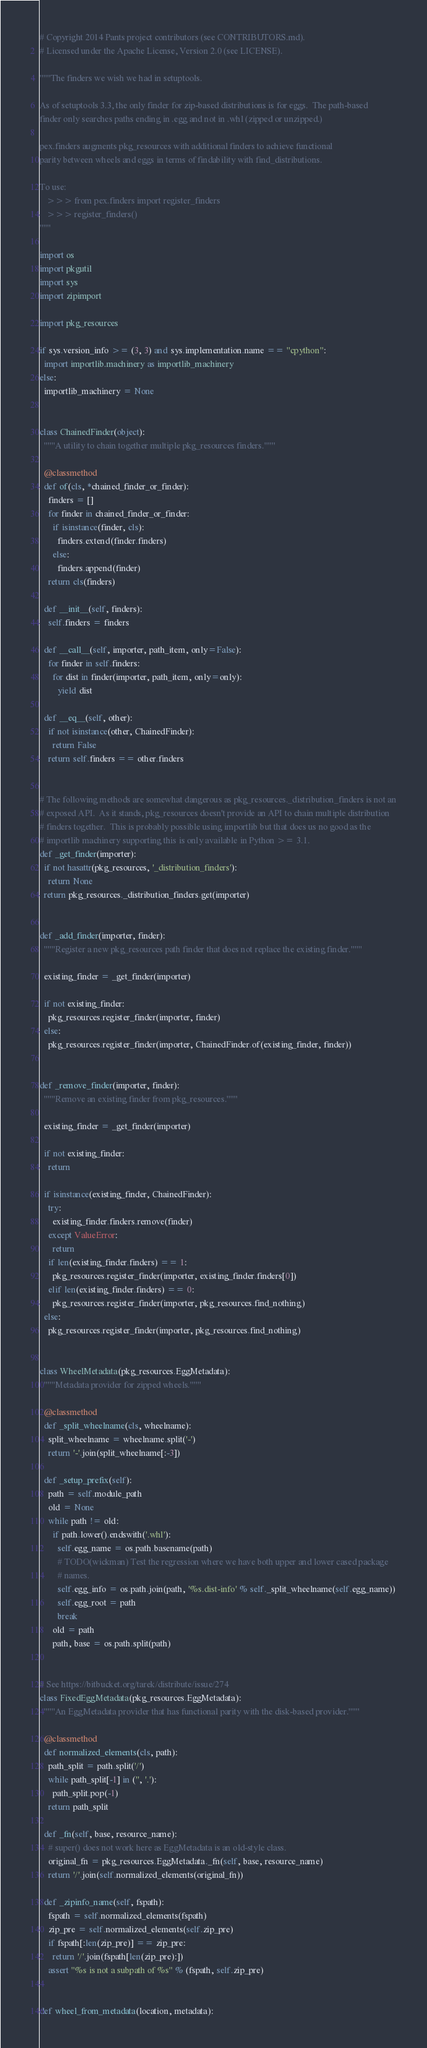<code> <loc_0><loc_0><loc_500><loc_500><_Python_># Copyright 2014 Pants project contributors (see CONTRIBUTORS.md).
# Licensed under the Apache License, Version 2.0 (see LICENSE).

"""The finders we wish we had in setuptools.

As of setuptools 3.3, the only finder for zip-based distributions is for eggs.  The path-based
finder only searches paths ending in .egg and not in .whl (zipped or unzipped.)

pex.finders augments pkg_resources with additional finders to achieve functional
parity between wheels and eggs in terms of findability with find_distributions.

To use:
   >>> from pex.finders import register_finders
   >>> register_finders()
"""

import os
import pkgutil
import sys
import zipimport

import pkg_resources

if sys.version_info >= (3, 3) and sys.implementation.name == "cpython":
  import importlib.machinery as importlib_machinery
else:
  importlib_machinery = None


class ChainedFinder(object):
  """A utility to chain together multiple pkg_resources finders."""

  @classmethod
  def of(cls, *chained_finder_or_finder):
    finders = []
    for finder in chained_finder_or_finder:
      if isinstance(finder, cls):
        finders.extend(finder.finders)
      else:
        finders.append(finder)
    return cls(finders)

  def __init__(self, finders):
    self.finders = finders

  def __call__(self, importer, path_item, only=False):
    for finder in self.finders:
      for dist in finder(importer, path_item, only=only):
        yield dist

  def __eq__(self, other):
    if not isinstance(other, ChainedFinder):
      return False
    return self.finders == other.finders


# The following methods are somewhat dangerous as pkg_resources._distribution_finders is not an
# exposed API.  As it stands, pkg_resources doesn't provide an API to chain multiple distribution
# finders together.  This is probably possible using importlib but that does us no good as the
# importlib machinery supporting this is only available in Python >= 3.1.
def _get_finder(importer):
  if not hasattr(pkg_resources, '_distribution_finders'):
    return None
  return pkg_resources._distribution_finders.get(importer)


def _add_finder(importer, finder):
  """Register a new pkg_resources path finder that does not replace the existing finder."""

  existing_finder = _get_finder(importer)

  if not existing_finder:
    pkg_resources.register_finder(importer, finder)
  else:
    pkg_resources.register_finder(importer, ChainedFinder.of(existing_finder, finder))


def _remove_finder(importer, finder):
  """Remove an existing finder from pkg_resources."""

  existing_finder = _get_finder(importer)

  if not existing_finder:
    return

  if isinstance(existing_finder, ChainedFinder):
    try:
      existing_finder.finders.remove(finder)
    except ValueError:
      return
    if len(existing_finder.finders) == 1:
      pkg_resources.register_finder(importer, existing_finder.finders[0])
    elif len(existing_finder.finders) == 0:
      pkg_resources.register_finder(importer, pkg_resources.find_nothing)
  else:
    pkg_resources.register_finder(importer, pkg_resources.find_nothing)


class WheelMetadata(pkg_resources.EggMetadata):
  """Metadata provider for zipped wheels."""

  @classmethod
  def _split_wheelname(cls, wheelname):
    split_wheelname = wheelname.split('-')
    return '-'.join(split_wheelname[:-3])

  def _setup_prefix(self):
    path = self.module_path
    old = None
    while path != old:
      if path.lower().endswith('.whl'):
        self.egg_name = os.path.basename(path)
        # TODO(wickman) Test the regression where we have both upper and lower cased package
        # names.
        self.egg_info = os.path.join(path, '%s.dist-info' % self._split_wheelname(self.egg_name))
        self.egg_root = path
        break
      old = path
      path, base = os.path.split(path)


# See https://bitbucket.org/tarek/distribute/issue/274
class FixedEggMetadata(pkg_resources.EggMetadata):
  """An EggMetadata provider that has functional parity with the disk-based provider."""

  @classmethod
  def normalized_elements(cls, path):
    path_split = path.split('/')
    while path_split[-1] in ('', '.'):
      path_split.pop(-1)
    return path_split

  def _fn(self, base, resource_name):
    # super() does not work here as EggMetadata is an old-style class.
    original_fn = pkg_resources.EggMetadata._fn(self, base, resource_name)
    return '/'.join(self.normalized_elements(original_fn))

  def _zipinfo_name(self, fspath):
    fspath = self.normalized_elements(fspath)
    zip_pre = self.normalized_elements(self.zip_pre)
    if fspath[:len(zip_pre)] == zip_pre:
      return '/'.join(fspath[len(zip_pre):])
    assert "%s is not a subpath of %s" % (fspath, self.zip_pre)


def wheel_from_metadata(location, metadata):</code> 